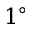Convert formula to latex. <formula><loc_0><loc_0><loc_500><loc_500>1 ^ { \circ }</formula> 